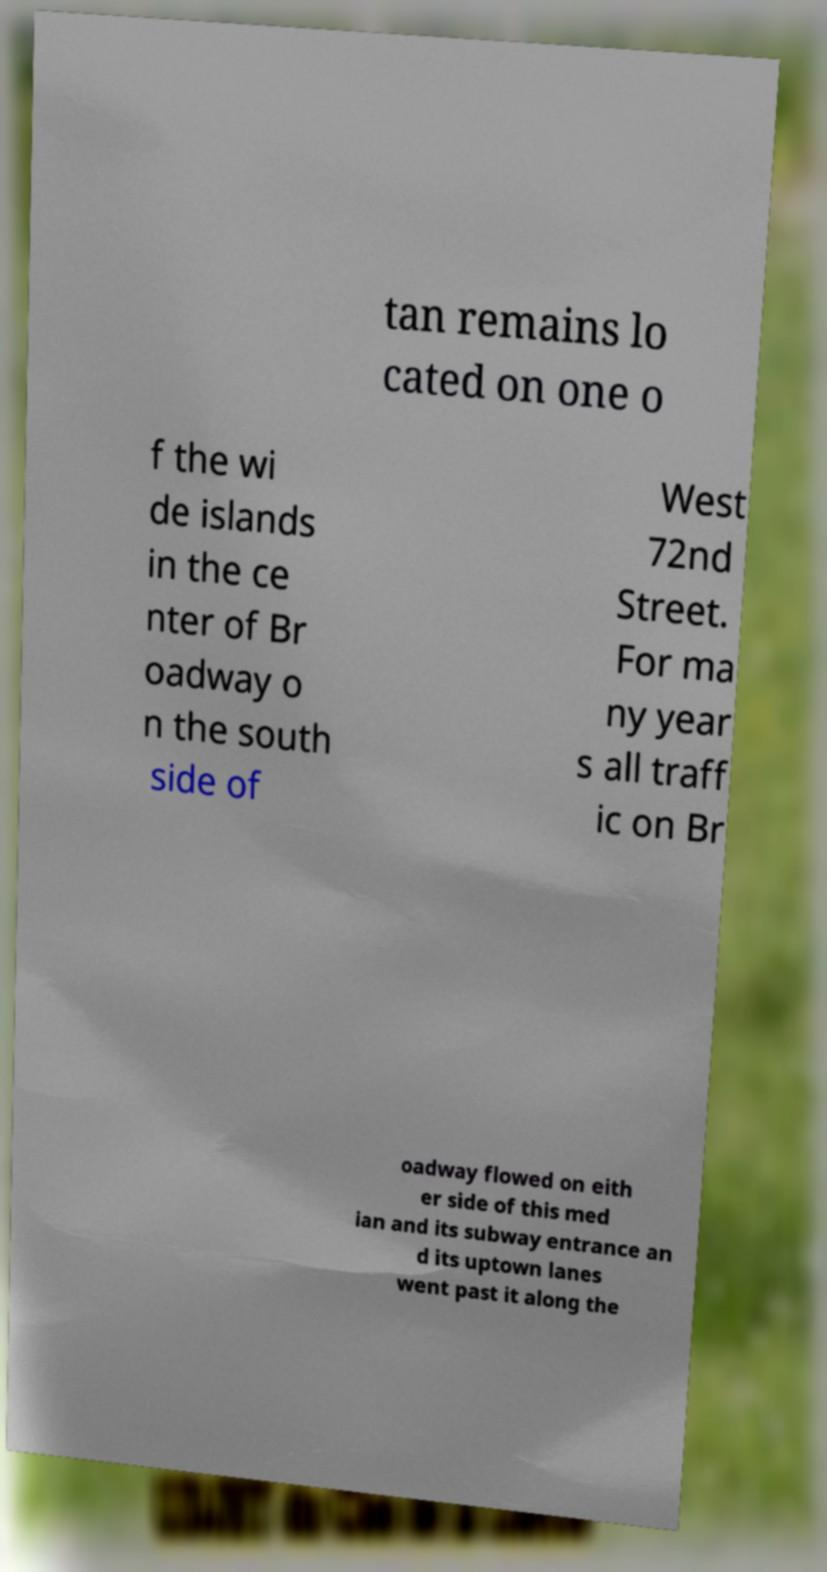Please identify and transcribe the text found in this image. tan remains lo cated on one o f the wi de islands in the ce nter of Br oadway o n the south side of West 72nd Street. For ma ny year s all traff ic on Br oadway flowed on eith er side of this med ian and its subway entrance an d its uptown lanes went past it along the 